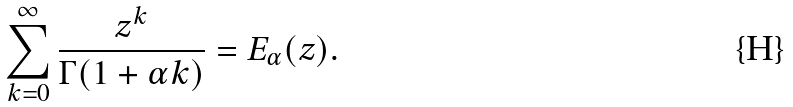<formula> <loc_0><loc_0><loc_500><loc_500>\sum _ { k = 0 } ^ { \infty } \frac { z ^ { k } } { \Gamma ( 1 + \alpha k ) } = E _ { \alpha } ( z ) .</formula> 